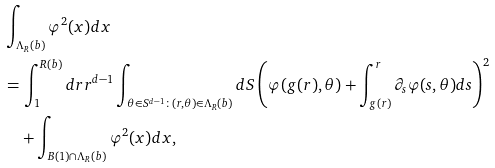<formula> <loc_0><loc_0><loc_500><loc_500>& \int _ { \Lambda _ { R } ( b ) } \varphi ^ { 2 } ( x ) d x \\ & = \int _ { 1 } ^ { R ( b ) } d r r ^ { d - 1 } \int _ { \theta \in S ^ { d - 1 } \colon ( r , \theta ) \in \Lambda _ { R } ( b ) } d S \left ( \varphi ( g ( r ) , \theta ) + \int _ { g ( r ) } ^ { r } \partial _ { s } \varphi ( s , \theta ) d s \right ) ^ { 2 } \\ & \quad + \int _ { B ( 1 ) \cap \Lambda _ { R } ( b ) } \varphi ^ { 2 } ( x ) d x ,</formula> 